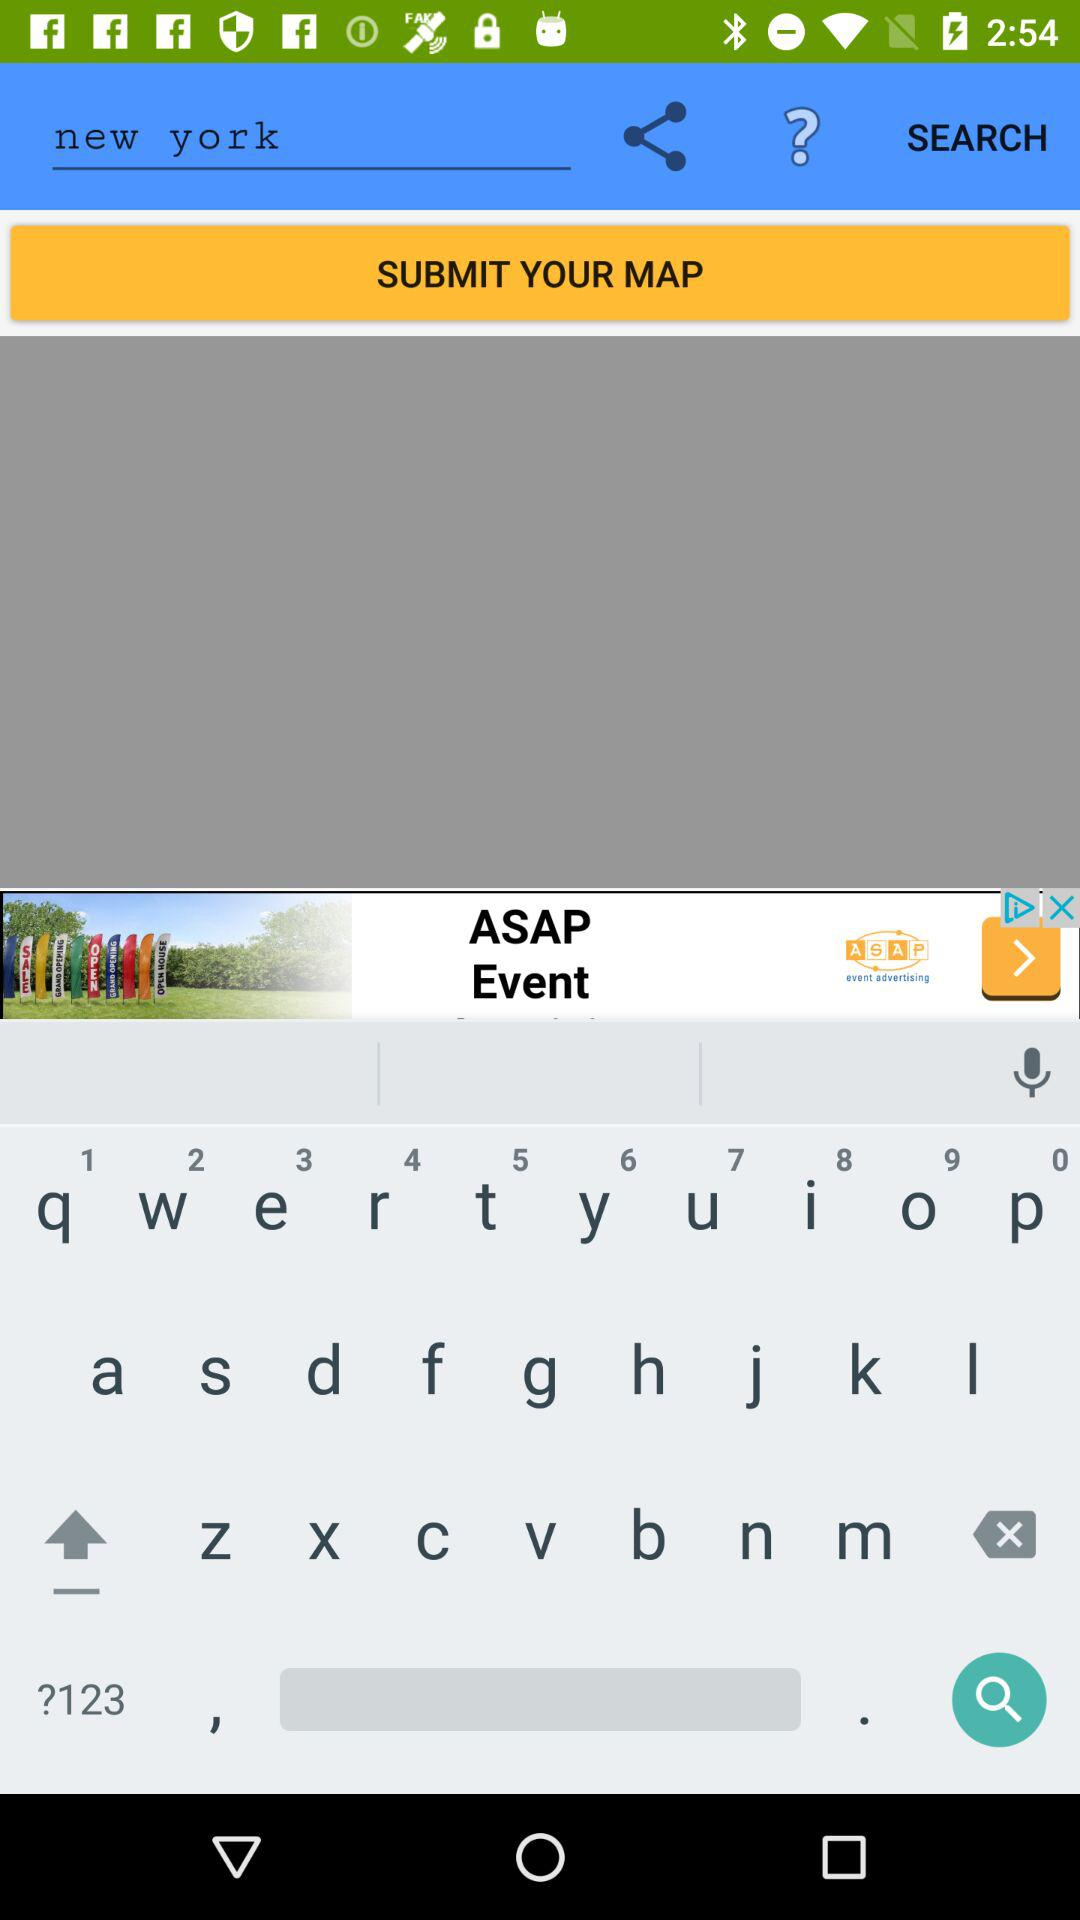What is the typed location? The typed location is New York. 